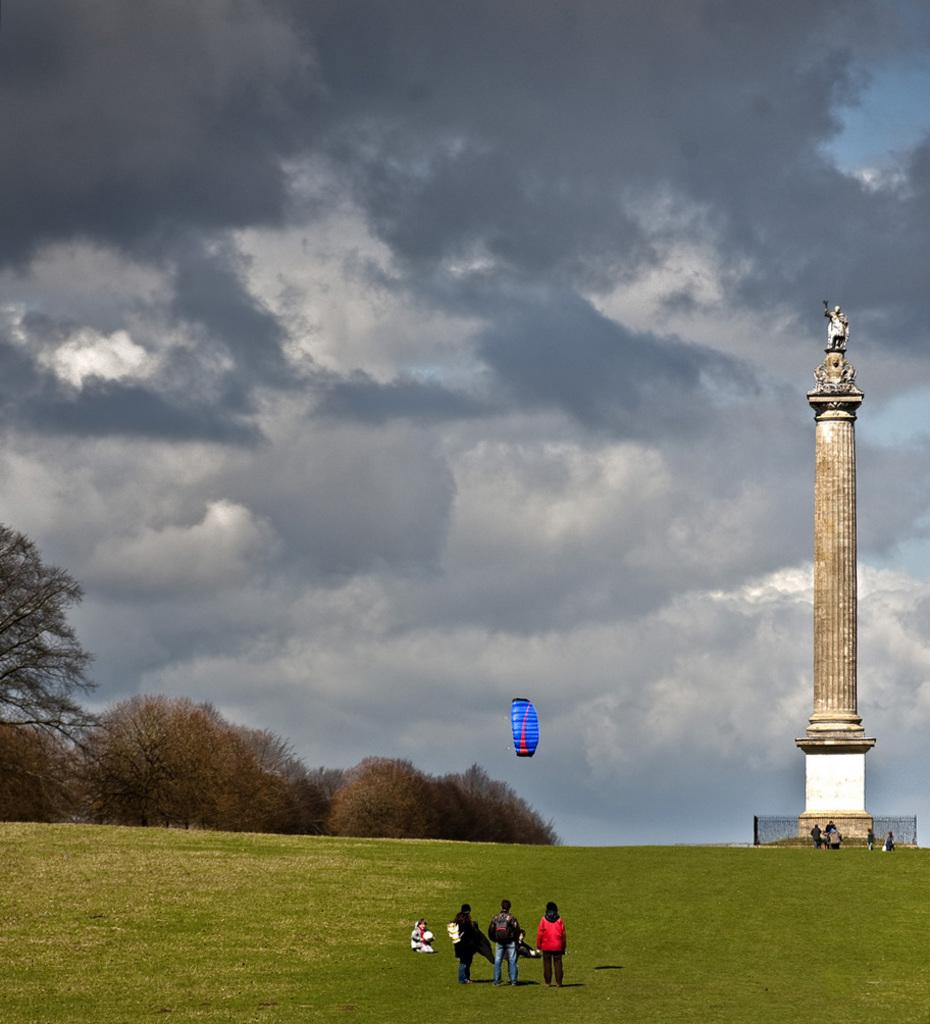What structure is located on the right side of the image? There is a tower on the right side of the image. Who or what can be seen in the image besides the tower? There are people visible in the image. What is in the center of the image? There is a parachute in the center of the image. What type of vegetation is present in the image? There are trees in the image. What is visible in the background of the image? The sky is visible in the background of the image. What type of cord is being used by the maid in the image? There is no maid or cord present in the image. What type of canvas is being used to paint the tower in the image? There is no painting or canvas present in the image. 